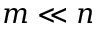<formula> <loc_0><loc_0><loc_500><loc_500>m \ll n</formula> 